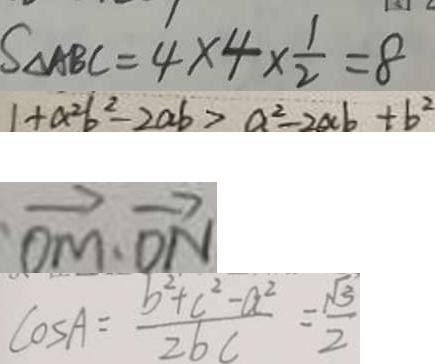Convert formula to latex. <formula><loc_0><loc_0><loc_500><loc_500>S _ { \Delta A B C } = 4 \times 4 \times \frac { 1 } { 2 } = 8 
 1 + a ^ { 2 } b ^ { 2 } - 2 a b > a ^ { 2 } - 2 a b + b ^ { 2 } 
 \overrightarrow { O M } \cdot \overrightarrow { D N } 
 \cos A = \frac { b ^ { 2 } + c ^ { 2 } - a ^ { 2 } } { 2 b c } = \frac { \sqrt { 3 } } { 2 }</formula> 